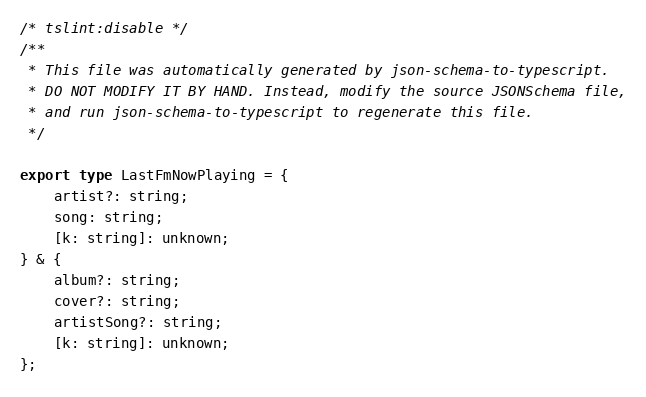Convert code to text. <code><loc_0><loc_0><loc_500><loc_500><_TypeScript_>/* tslint:disable */
/**
 * This file was automatically generated by json-schema-to-typescript.
 * DO NOT MODIFY IT BY HAND. Instead, modify the source JSONSchema file,
 * and run json-schema-to-typescript to regenerate this file.
 */

export type LastFmNowPlaying = {
	artist?: string;
	song: string;
	[k: string]: unknown;
} & {
	album?: string;
	cover?: string;
	artistSong?: string;
	[k: string]: unknown;
};
</code> 